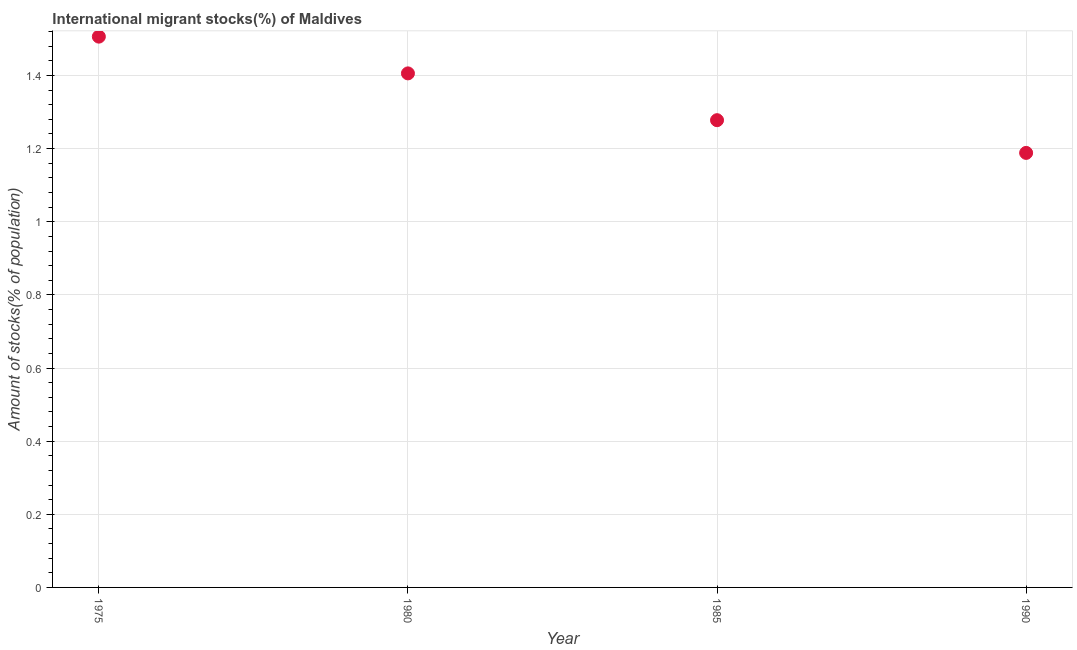What is the number of international migrant stocks in 1980?
Your answer should be very brief. 1.41. Across all years, what is the maximum number of international migrant stocks?
Offer a very short reply. 1.51. Across all years, what is the minimum number of international migrant stocks?
Give a very brief answer. 1.19. In which year was the number of international migrant stocks maximum?
Your answer should be compact. 1975. What is the sum of the number of international migrant stocks?
Keep it short and to the point. 5.38. What is the difference between the number of international migrant stocks in 1975 and 1990?
Make the answer very short. 0.32. What is the average number of international migrant stocks per year?
Your answer should be compact. 1.34. What is the median number of international migrant stocks?
Ensure brevity in your answer.  1.34. What is the ratio of the number of international migrant stocks in 1975 to that in 1985?
Your answer should be compact. 1.18. Is the number of international migrant stocks in 1980 less than that in 1990?
Keep it short and to the point. No. What is the difference between the highest and the second highest number of international migrant stocks?
Give a very brief answer. 0.1. Is the sum of the number of international migrant stocks in 1975 and 1985 greater than the maximum number of international migrant stocks across all years?
Offer a terse response. Yes. What is the difference between the highest and the lowest number of international migrant stocks?
Provide a short and direct response. 0.32. In how many years, is the number of international migrant stocks greater than the average number of international migrant stocks taken over all years?
Your response must be concise. 2. Does the number of international migrant stocks monotonically increase over the years?
Keep it short and to the point. No. How many dotlines are there?
Offer a very short reply. 1. How many years are there in the graph?
Your answer should be very brief. 4. Are the values on the major ticks of Y-axis written in scientific E-notation?
Ensure brevity in your answer.  No. Does the graph contain grids?
Offer a very short reply. Yes. What is the title of the graph?
Give a very brief answer. International migrant stocks(%) of Maldives. What is the label or title of the X-axis?
Make the answer very short. Year. What is the label or title of the Y-axis?
Offer a terse response. Amount of stocks(% of population). What is the Amount of stocks(% of population) in 1975?
Offer a terse response. 1.51. What is the Amount of stocks(% of population) in 1980?
Offer a terse response. 1.41. What is the Amount of stocks(% of population) in 1985?
Ensure brevity in your answer.  1.28. What is the Amount of stocks(% of population) in 1990?
Ensure brevity in your answer.  1.19. What is the difference between the Amount of stocks(% of population) in 1975 and 1980?
Offer a terse response. 0.1. What is the difference between the Amount of stocks(% of population) in 1975 and 1985?
Give a very brief answer. 0.23. What is the difference between the Amount of stocks(% of population) in 1975 and 1990?
Ensure brevity in your answer.  0.32. What is the difference between the Amount of stocks(% of population) in 1980 and 1985?
Provide a short and direct response. 0.13. What is the difference between the Amount of stocks(% of population) in 1980 and 1990?
Your answer should be compact. 0.22. What is the difference between the Amount of stocks(% of population) in 1985 and 1990?
Make the answer very short. 0.09. What is the ratio of the Amount of stocks(% of population) in 1975 to that in 1980?
Offer a very short reply. 1.07. What is the ratio of the Amount of stocks(% of population) in 1975 to that in 1985?
Your answer should be compact. 1.18. What is the ratio of the Amount of stocks(% of population) in 1975 to that in 1990?
Provide a short and direct response. 1.27. What is the ratio of the Amount of stocks(% of population) in 1980 to that in 1990?
Your response must be concise. 1.18. What is the ratio of the Amount of stocks(% of population) in 1985 to that in 1990?
Provide a short and direct response. 1.07. 